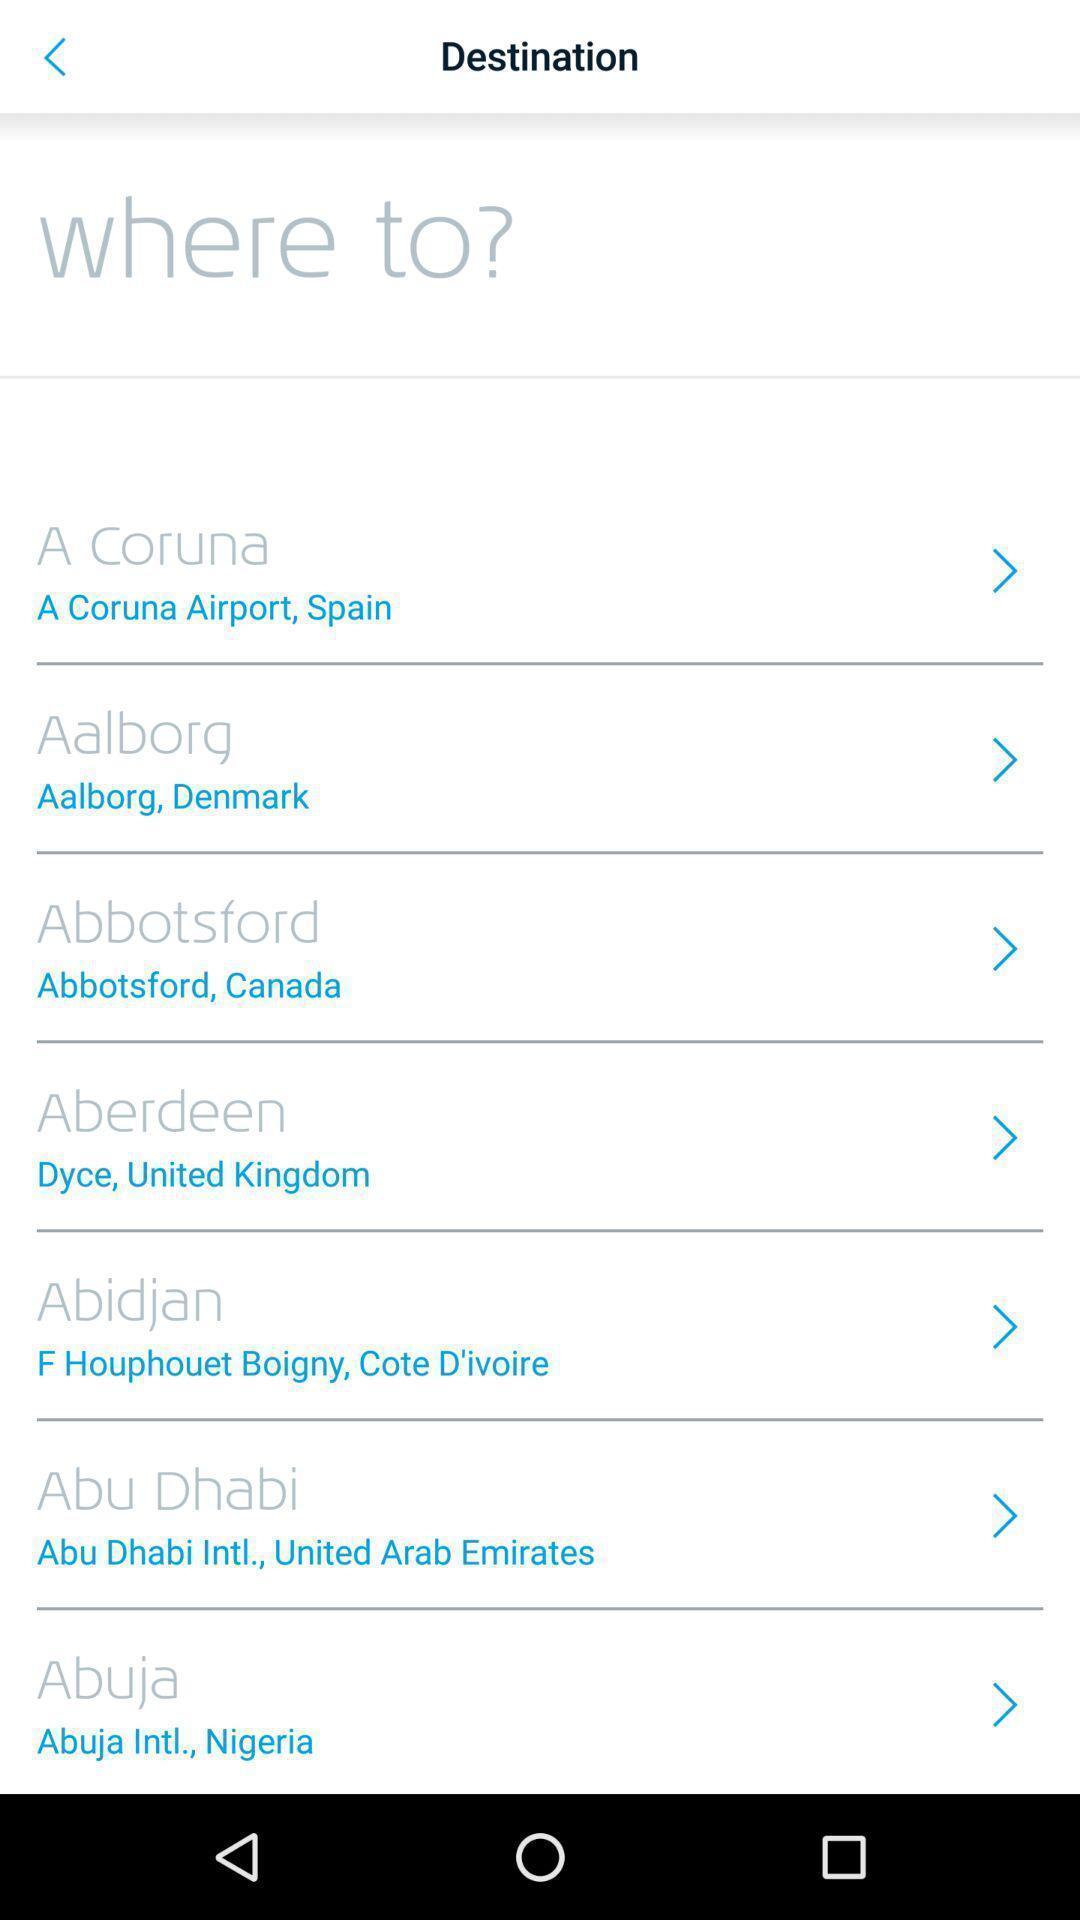Provide a detailed account of this screenshot. Search page for searching a destinations for flights. 